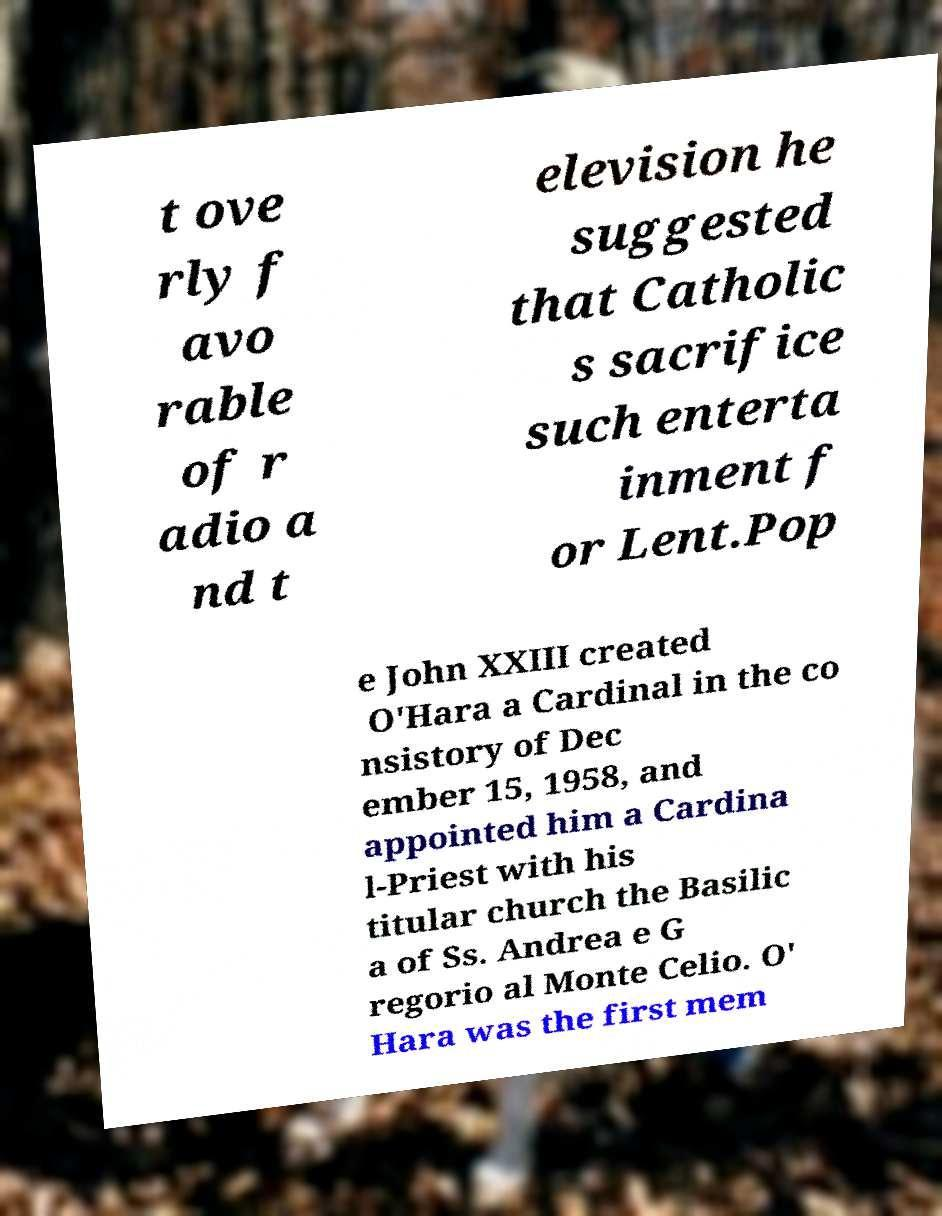What messages or text are displayed in this image? I need them in a readable, typed format. t ove rly f avo rable of r adio a nd t elevision he suggested that Catholic s sacrifice such enterta inment f or Lent.Pop e John XXIII created O'Hara a Cardinal in the co nsistory of Dec ember 15, 1958, and appointed him a Cardina l-Priest with his titular church the Basilic a of Ss. Andrea e G regorio al Monte Celio. O' Hara was the first mem 